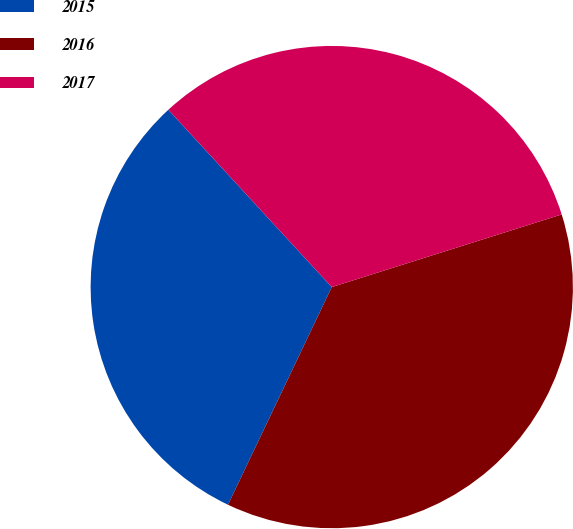Convert chart. <chart><loc_0><loc_0><loc_500><loc_500><pie_chart><fcel>2015<fcel>2016<fcel>2017<nl><fcel>31.07%<fcel>36.95%<fcel>31.98%<nl></chart> 